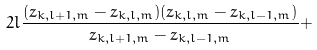<formula> <loc_0><loc_0><loc_500><loc_500>2 l \frac { ( z _ { k , l + 1 , m } - z _ { k , l , m } ) ( z _ { k , l , m } - z _ { k , l - 1 , m } ) } { z _ { k , l + 1 , m } - z _ { k , l - 1 , m } } +</formula> 